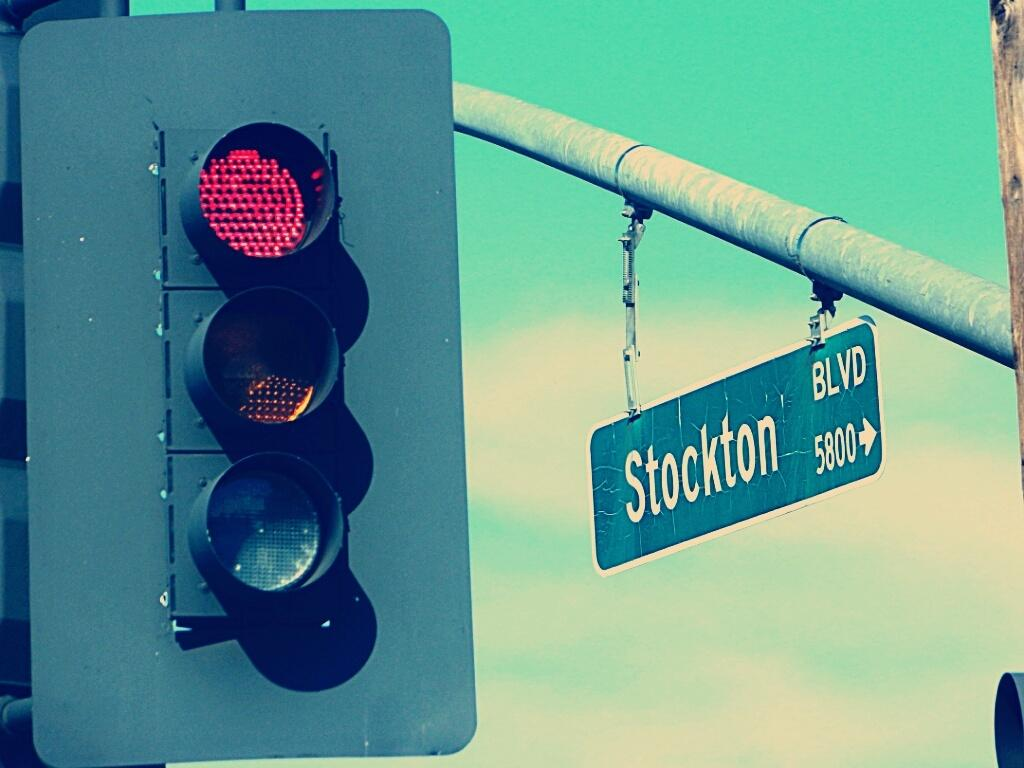<image>
Give a short and clear explanation of the subsequent image. A blue Stockton Blvd street sign hangs next to a stop light. 